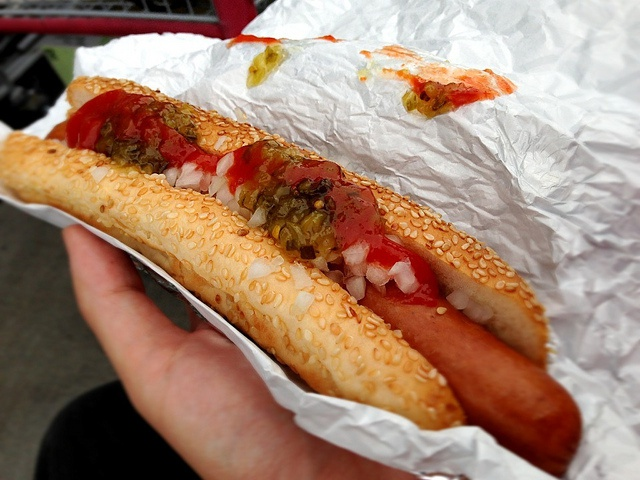Describe the objects in this image and their specific colors. I can see hot dog in gray, tan, brown, and maroon tones and people in gray, brown, black, and salmon tones in this image. 